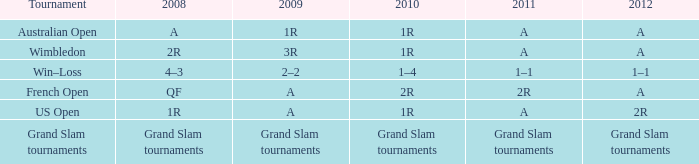Name the 2011 for 2012 of a and 2010 of 1r with 2008 of 2r A. 